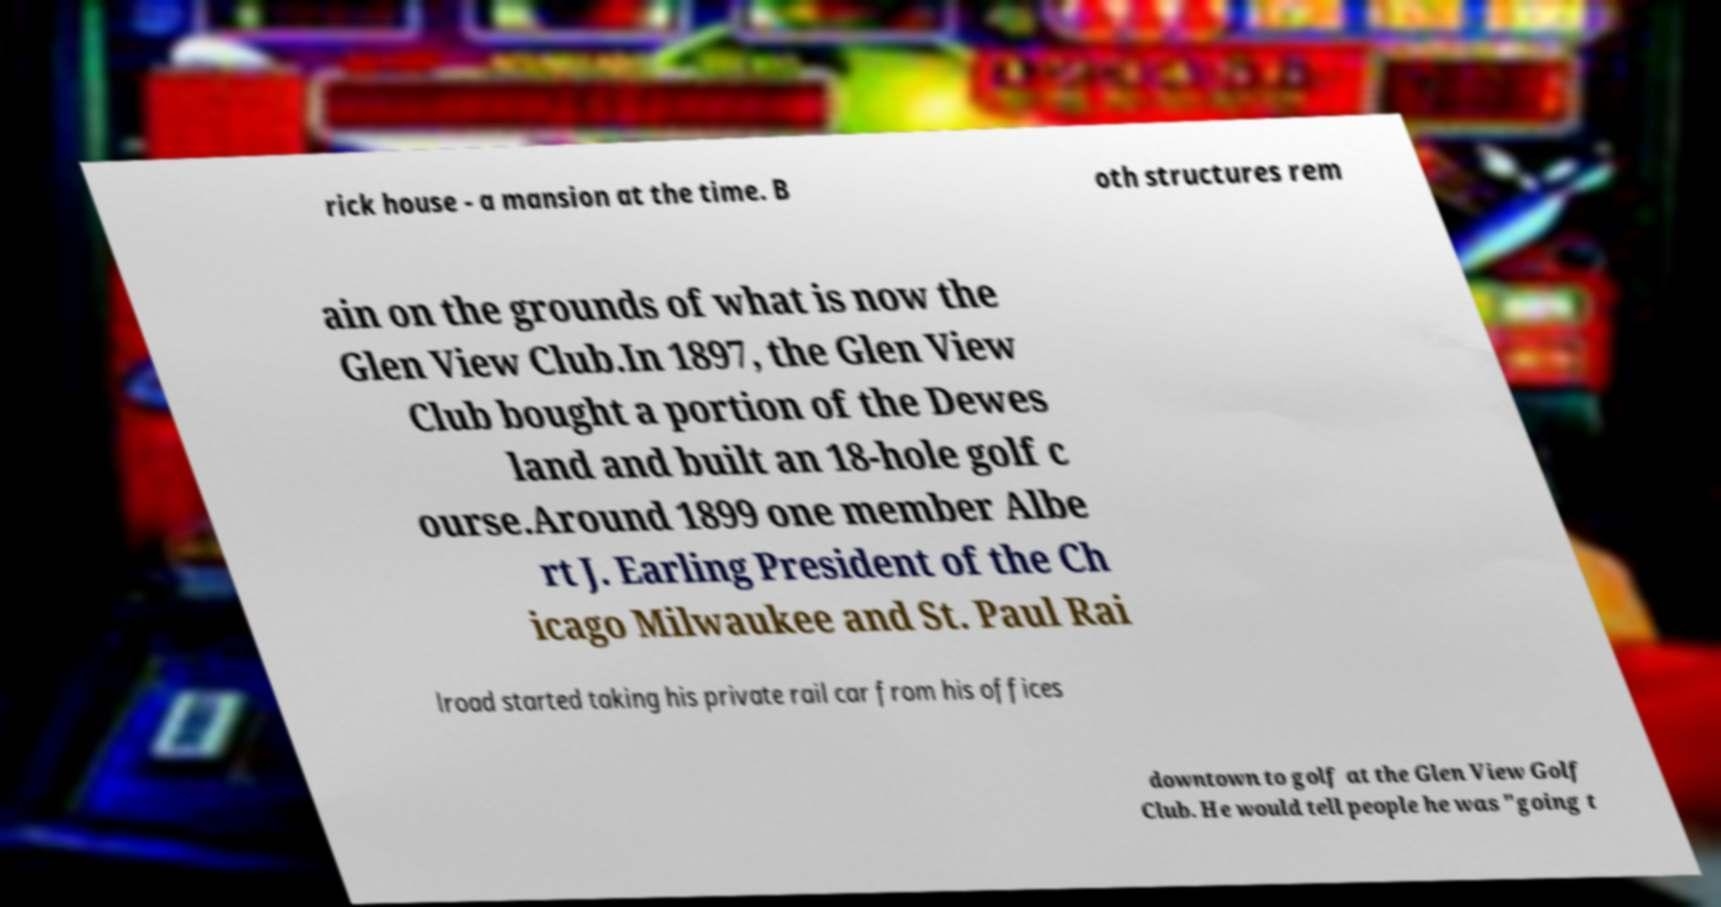There's text embedded in this image that I need extracted. Can you transcribe it verbatim? rick house - a mansion at the time. B oth structures rem ain on the grounds of what is now the Glen View Club.In 1897, the Glen View Club bought a portion of the Dewes land and built an 18-hole golf c ourse.Around 1899 one member Albe rt J. Earling President of the Ch icago Milwaukee and St. Paul Rai lroad started taking his private rail car from his offices downtown to golf at the Glen View Golf Club. He would tell people he was "going t 